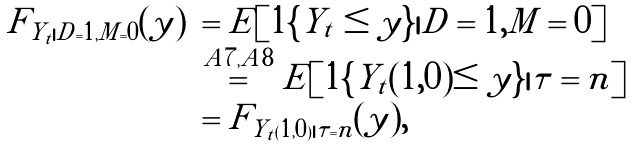<formula> <loc_0><loc_0><loc_500><loc_500>\begin{array} { r l } F _ { Y _ { t } | D = 1 , M = 0 } ( y ) & = E [ 1 \{ Y _ { t } \leq y \} | D = 1 , M = 0 ] \\ & \stackrel { A 7 , A 8 } { = } E [ 1 \{ Y _ { t } ( 1 , 0 ) \leq y \} | \tau = n ] \\ & = F _ { Y _ { t } ( 1 , 0 ) | \tau = n } ( y ) , \end{array}</formula> 